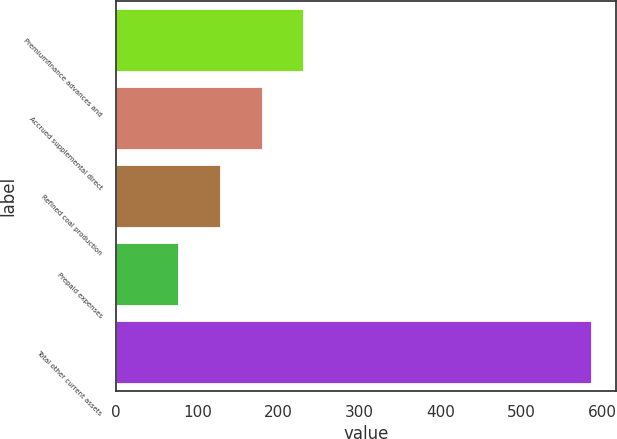Convert chart to OTSL. <chart><loc_0><loc_0><loc_500><loc_500><bar_chart><fcel>Premiumfinance advances and<fcel>Accrued supplemental direct<fcel>Refined coal production<fcel>Prepaid expenses<fcel>Total other current assets<nl><fcel>232.04<fcel>181.1<fcel>128.74<fcel>77.8<fcel>587.2<nl></chart> 